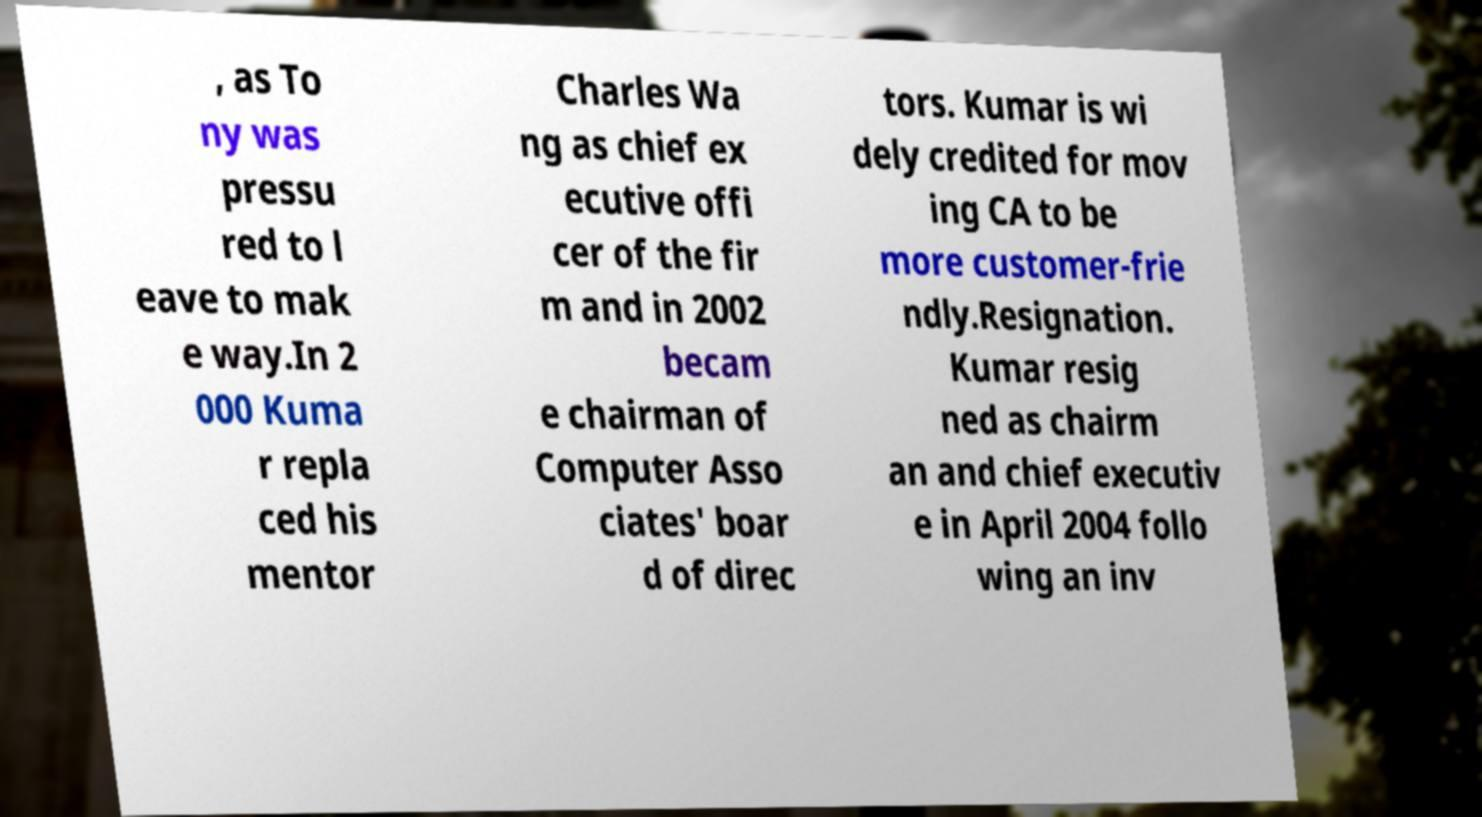Please identify and transcribe the text found in this image. , as To ny was pressu red to l eave to mak e way.In 2 000 Kuma r repla ced his mentor Charles Wa ng as chief ex ecutive offi cer of the fir m and in 2002 becam e chairman of Computer Asso ciates' boar d of direc tors. Kumar is wi dely credited for mov ing CA to be more customer-frie ndly.Resignation. Kumar resig ned as chairm an and chief executiv e in April 2004 follo wing an inv 